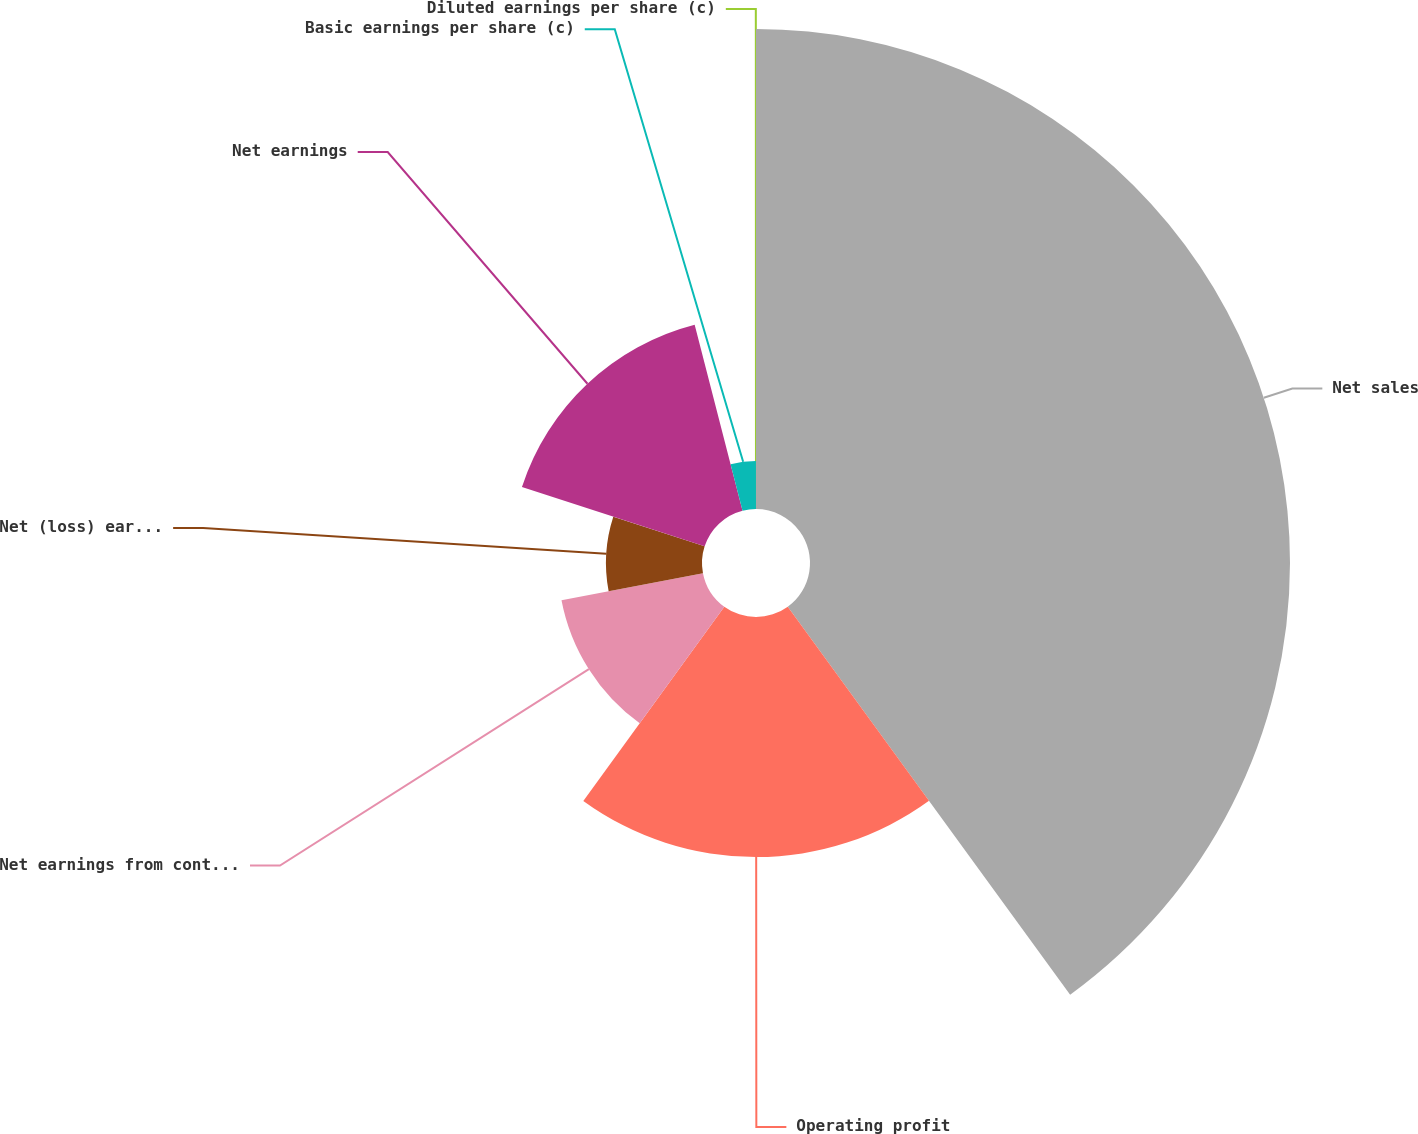Convert chart to OTSL. <chart><loc_0><loc_0><loc_500><loc_500><pie_chart><fcel>Net sales<fcel>Operating profit<fcel>Net earnings from continuing<fcel>Net (loss) earnings from<fcel>Net earnings<fcel>Basic earnings per share (c)<fcel>Diluted earnings per share (c)<nl><fcel>39.99%<fcel>20.0%<fcel>12.0%<fcel>8.0%<fcel>16.0%<fcel>4.0%<fcel>0.01%<nl></chart> 